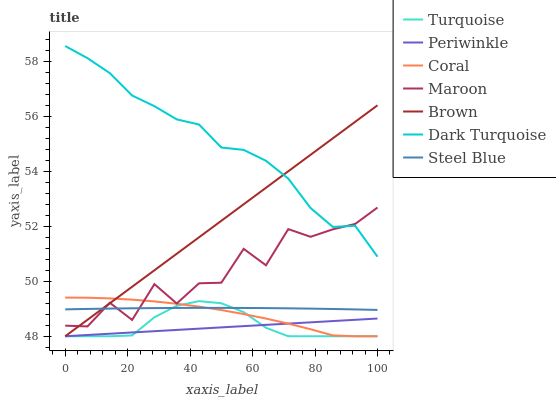Does Periwinkle have the minimum area under the curve?
Answer yes or no. Yes. Does Dark Turquoise have the maximum area under the curve?
Answer yes or no. Yes. Does Turquoise have the minimum area under the curve?
Answer yes or no. No. Does Turquoise have the maximum area under the curve?
Answer yes or no. No. Is Brown the smoothest?
Answer yes or no. Yes. Is Maroon the roughest?
Answer yes or no. Yes. Is Turquoise the smoothest?
Answer yes or no. No. Is Turquoise the roughest?
Answer yes or no. No. Does Brown have the lowest value?
Answer yes or no. Yes. Does Dark Turquoise have the lowest value?
Answer yes or no. No. Does Dark Turquoise have the highest value?
Answer yes or no. Yes. Does Turquoise have the highest value?
Answer yes or no. No. Is Periwinkle less than Dark Turquoise?
Answer yes or no. Yes. Is Dark Turquoise greater than Turquoise?
Answer yes or no. Yes. Does Turquoise intersect Periwinkle?
Answer yes or no. Yes. Is Turquoise less than Periwinkle?
Answer yes or no. No. Is Turquoise greater than Periwinkle?
Answer yes or no. No. Does Periwinkle intersect Dark Turquoise?
Answer yes or no. No. 